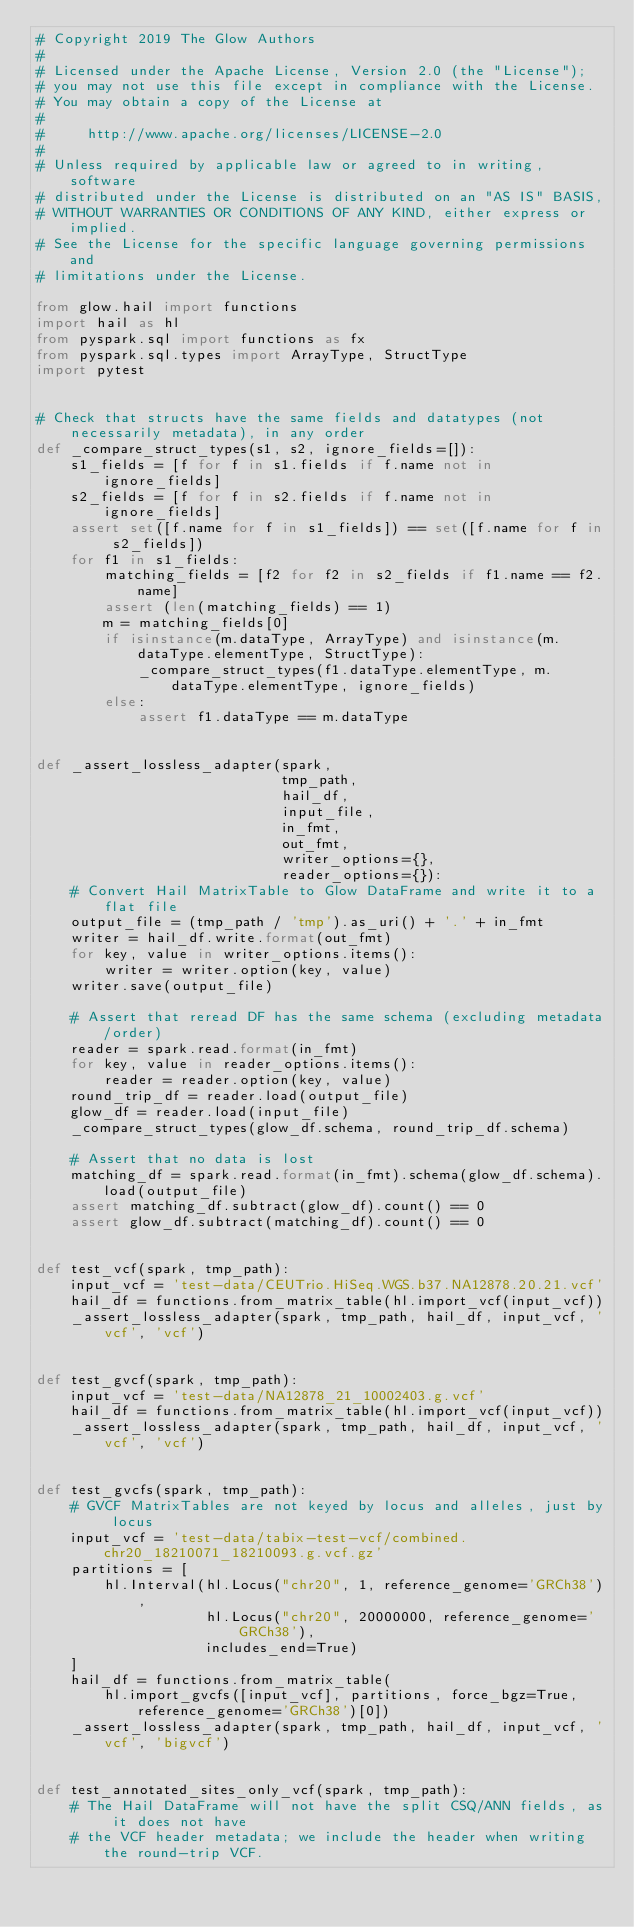Convert code to text. <code><loc_0><loc_0><loc_500><loc_500><_Python_># Copyright 2019 The Glow Authors
#
# Licensed under the Apache License, Version 2.0 (the "License");
# you may not use this file except in compliance with the License.
# You may obtain a copy of the License at
#
#     http://www.apache.org/licenses/LICENSE-2.0
#
# Unless required by applicable law or agreed to in writing, software
# distributed under the License is distributed on an "AS IS" BASIS,
# WITHOUT WARRANTIES OR CONDITIONS OF ANY KIND, either express or implied.
# See the License for the specific language governing permissions and
# limitations under the License.

from glow.hail import functions
import hail as hl
from pyspark.sql import functions as fx
from pyspark.sql.types import ArrayType, StructType
import pytest


# Check that structs have the same fields and datatypes (not necessarily metadata), in any order
def _compare_struct_types(s1, s2, ignore_fields=[]):
    s1_fields = [f for f in s1.fields if f.name not in ignore_fields]
    s2_fields = [f for f in s2.fields if f.name not in ignore_fields]
    assert set([f.name for f in s1_fields]) == set([f.name for f in s2_fields])
    for f1 in s1_fields:
        matching_fields = [f2 for f2 in s2_fields if f1.name == f2.name]
        assert (len(matching_fields) == 1)
        m = matching_fields[0]
        if isinstance(m.dataType, ArrayType) and isinstance(m.dataType.elementType, StructType):
            _compare_struct_types(f1.dataType.elementType, m.dataType.elementType, ignore_fields)
        else:
            assert f1.dataType == m.dataType


def _assert_lossless_adapter(spark,
                             tmp_path,
                             hail_df,
                             input_file,
                             in_fmt,
                             out_fmt,
                             writer_options={},
                             reader_options={}):
    # Convert Hail MatrixTable to Glow DataFrame and write it to a flat file
    output_file = (tmp_path / 'tmp').as_uri() + '.' + in_fmt
    writer = hail_df.write.format(out_fmt)
    for key, value in writer_options.items():
        writer = writer.option(key, value)
    writer.save(output_file)

    # Assert that reread DF has the same schema (excluding metadata/order)
    reader = spark.read.format(in_fmt)
    for key, value in reader_options.items():
        reader = reader.option(key, value)
    round_trip_df = reader.load(output_file)
    glow_df = reader.load(input_file)
    _compare_struct_types(glow_df.schema, round_trip_df.schema)

    # Assert that no data is lost
    matching_df = spark.read.format(in_fmt).schema(glow_df.schema).load(output_file)
    assert matching_df.subtract(glow_df).count() == 0
    assert glow_df.subtract(matching_df).count() == 0


def test_vcf(spark, tmp_path):
    input_vcf = 'test-data/CEUTrio.HiSeq.WGS.b37.NA12878.20.21.vcf'
    hail_df = functions.from_matrix_table(hl.import_vcf(input_vcf))
    _assert_lossless_adapter(spark, tmp_path, hail_df, input_vcf, 'vcf', 'vcf')


def test_gvcf(spark, tmp_path):
    input_vcf = 'test-data/NA12878_21_10002403.g.vcf'
    hail_df = functions.from_matrix_table(hl.import_vcf(input_vcf))
    _assert_lossless_adapter(spark, tmp_path, hail_df, input_vcf, 'vcf', 'vcf')


def test_gvcfs(spark, tmp_path):
    # GVCF MatrixTables are not keyed by locus and alleles, just by locus
    input_vcf = 'test-data/tabix-test-vcf/combined.chr20_18210071_18210093.g.vcf.gz'
    partitions = [
        hl.Interval(hl.Locus("chr20", 1, reference_genome='GRCh38'),
                    hl.Locus("chr20", 20000000, reference_genome='GRCh38'),
                    includes_end=True)
    ]
    hail_df = functions.from_matrix_table(
        hl.import_gvcfs([input_vcf], partitions, force_bgz=True, reference_genome='GRCh38')[0])
    _assert_lossless_adapter(spark, tmp_path, hail_df, input_vcf, 'vcf', 'bigvcf')


def test_annotated_sites_only_vcf(spark, tmp_path):
    # The Hail DataFrame will not have the split CSQ/ANN fields, as it does not have
    # the VCF header metadata; we include the header when writing the round-trip VCF.</code> 